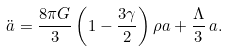Convert formula to latex. <formula><loc_0><loc_0><loc_500><loc_500>\ddot { a } = \frac { 8 \pi G } { 3 } \left ( 1 - \frac { 3 \gamma } { 2 } \right ) \rho a + \frac { \Lambda } { 3 } \, a .</formula> 